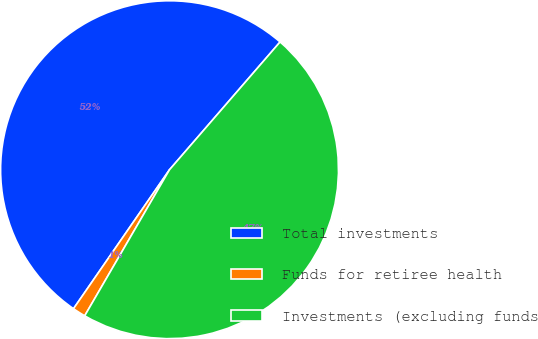<chart> <loc_0><loc_0><loc_500><loc_500><pie_chart><fcel>Total investments<fcel>Funds for retiree health<fcel>Investments (excluding funds<nl><fcel>51.73%<fcel>1.25%<fcel>47.02%<nl></chart> 